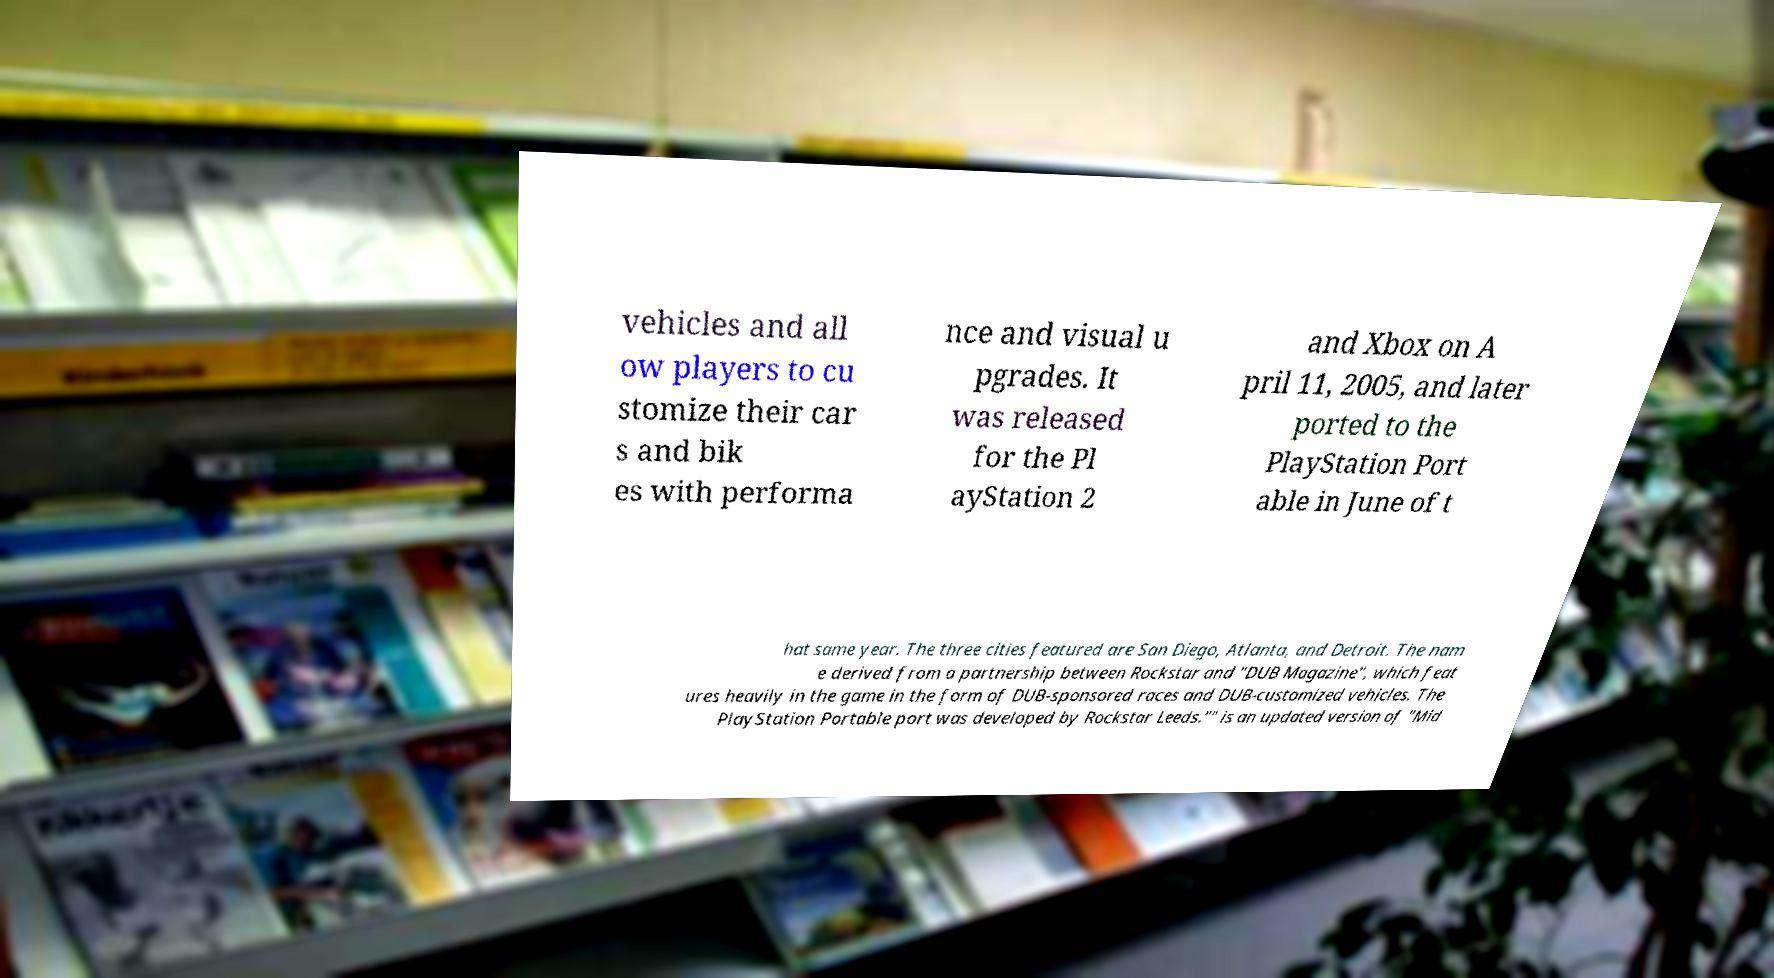There's text embedded in this image that I need extracted. Can you transcribe it verbatim? vehicles and all ow players to cu stomize their car s and bik es with performa nce and visual u pgrades. It was released for the Pl ayStation 2 and Xbox on A pril 11, 2005, and later ported to the PlayStation Port able in June of t hat same year. The three cities featured are San Diego, Atlanta, and Detroit. The nam e derived from a partnership between Rockstar and "DUB Magazine", which feat ures heavily in the game in the form of DUB-sponsored races and DUB-customized vehicles. The PlayStation Portable port was developed by Rockstar Leeds."" is an updated version of "Mid 